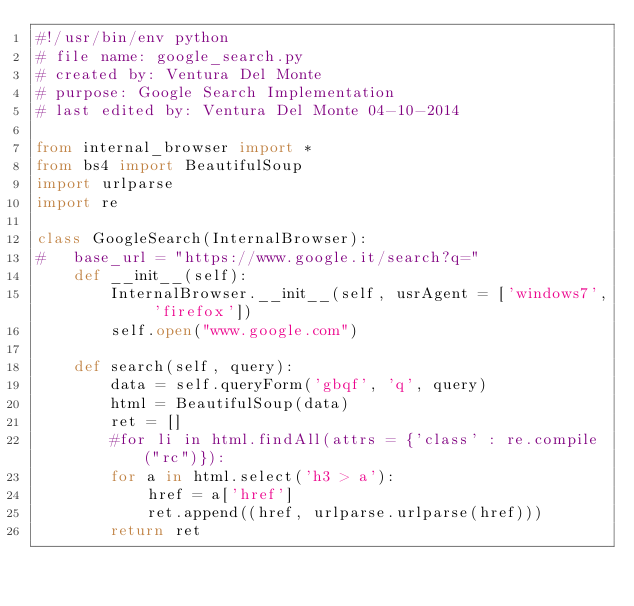Convert code to text. <code><loc_0><loc_0><loc_500><loc_500><_Python_>#!/usr/bin/env python
# file name: google_search.py
# created by: Ventura Del Monte 
# purpose: Google Search Implementation 
# last edited by: Ventura Del Monte 04-10-2014

from internal_browser import *
from bs4 import BeautifulSoup
import urlparse
import re

class GoogleSearch(InternalBrowser):
#	base_url = "https://www.google.it/search?q="
	def __init__(self):
		InternalBrowser.__init__(self, usrAgent = ['windows7', 'firefox'])
		self.open("www.google.com")
	
	def search(self, query):
		data = self.queryForm('gbqf', 'q', query)
		html = BeautifulSoup(data)
		ret = []
		#for li in html.findAll(attrs = {'class' : re.compile("rc")}):
		for a in html.select('h3 > a'):
			href = a['href']
			ret.append((href, urlparse.urlparse(href)))
		return ret
		
	
</code> 